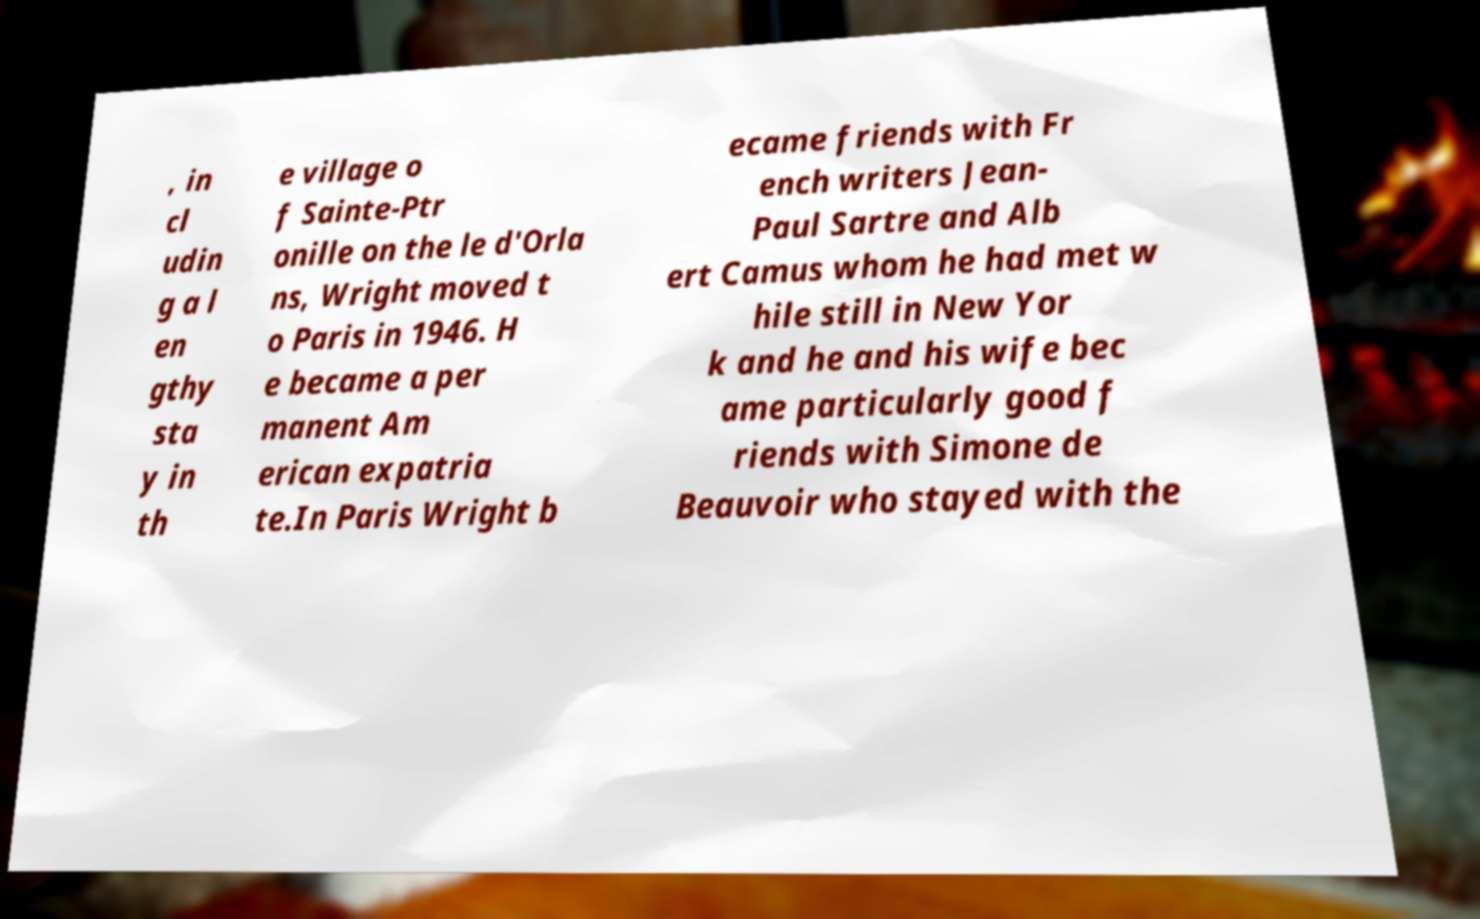I need the written content from this picture converted into text. Can you do that? , in cl udin g a l en gthy sta y in th e village o f Sainte-Ptr onille on the le d'Orla ns, Wright moved t o Paris in 1946. H e became a per manent Am erican expatria te.In Paris Wright b ecame friends with Fr ench writers Jean- Paul Sartre and Alb ert Camus whom he had met w hile still in New Yor k and he and his wife bec ame particularly good f riends with Simone de Beauvoir who stayed with the 